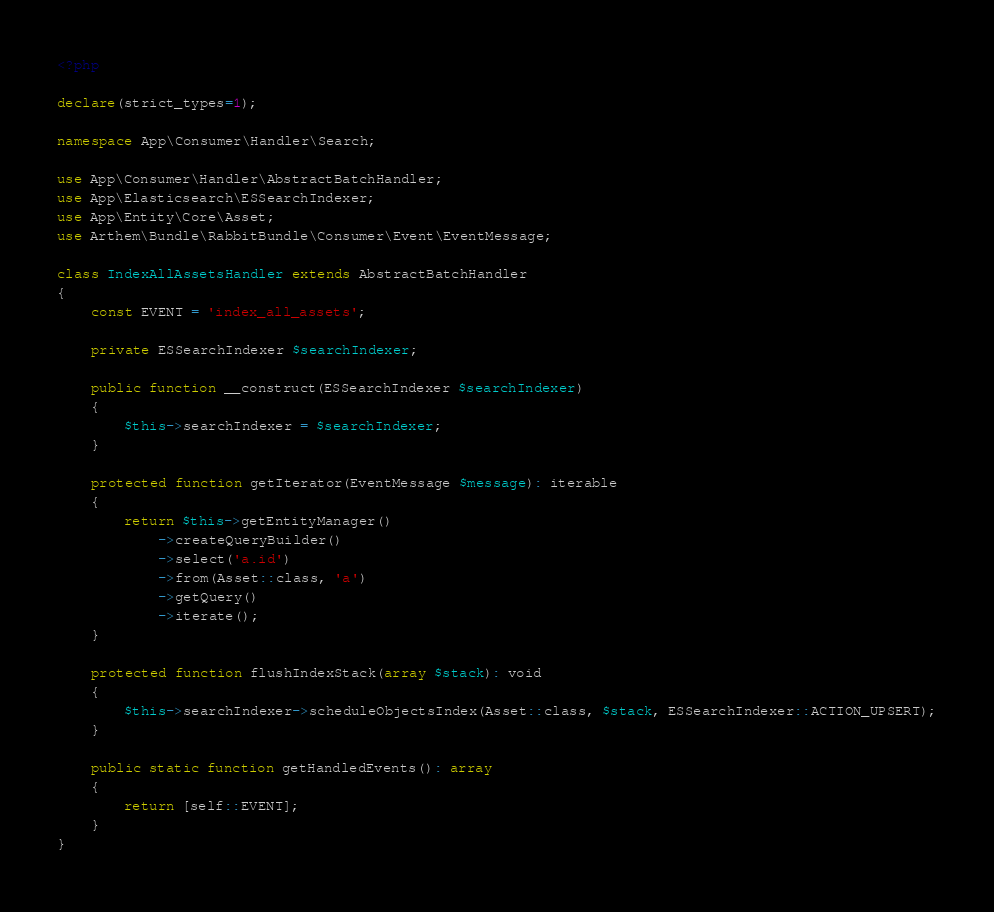<code> <loc_0><loc_0><loc_500><loc_500><_PHP_><?php

declare(strict_types=1);

namespace App\Consumer\Handler\Search;

use App\Consumer\Handler\AbstractBatchHandler;
use App\Elasticsearch\ESSearchIndexer;
use App\Entity\Core\Asset;
use Arthem\Bundle\RabbitBundle\Consumer\Event\EventMessage;

class IndexAllAssetsHandler extends AbstractBatchHandler
{
    const EVENT = 'index_all_assets';

    private ESSearchIndexer $searchIndexer;

    public function __construct(ESSearchIndexer $searchIndexer)
    {
        $this->searchIndexer = $searchIndexer;
    }

    protected function getIterator(EventMessage $message): iterable
    {
        return $this->getEntityManager()
            ->createQueryBuilder()
            ->select('a.id')
            ->from(Asset::class, 'a')
            ->getQuery()
            ->iterate();
    }

    protected function flushIndexStack(array $stack): void
    {
        $this->searchIndexer->scheduleObjectsIndex(Asset::class, $stack, ESSearchIndexer::ACTION_UPSERT);
    }

    public static function getHandledEvents(): array
    {
        return [self::EVENT];
    }
}
</code> 